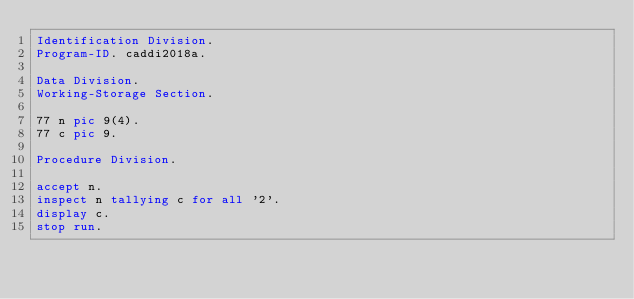Convert code to text. <code><loc_0><loc_0><loc_500><loc_500><_COBOL_>Identification Division.
Program-ID. caddi2018a.

Data Division.
Working-Storage Section.

77 n pic 9(4).
77 c pic 9.

Procedure Division.

accept n.
inspect n tallying c for all '2'.
display c.
stop run.
</code> 